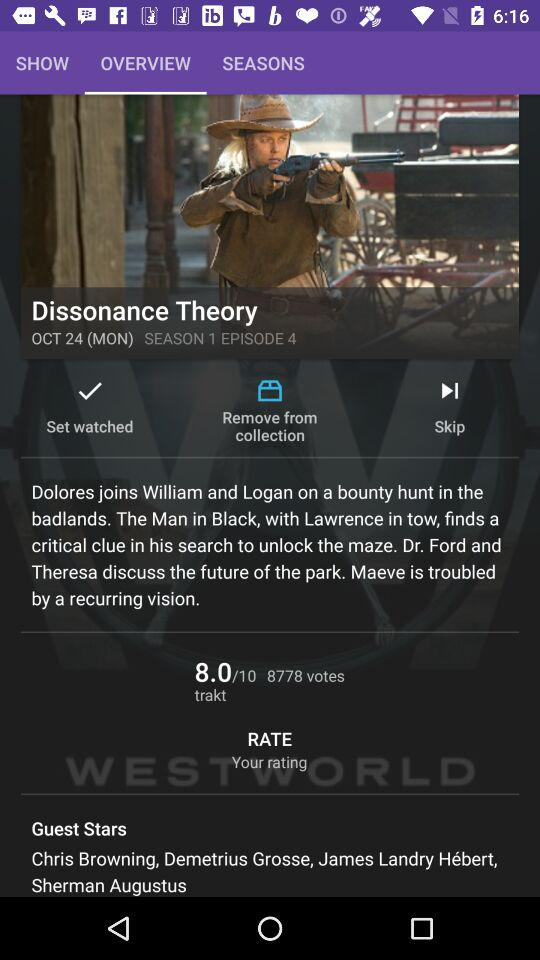What is the name of the episode? The name of the episode is "Dissonance Theory". 